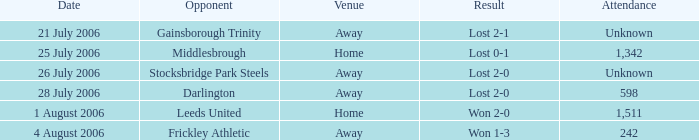What is the result from the Leeds United opponent? Won 2-0. 